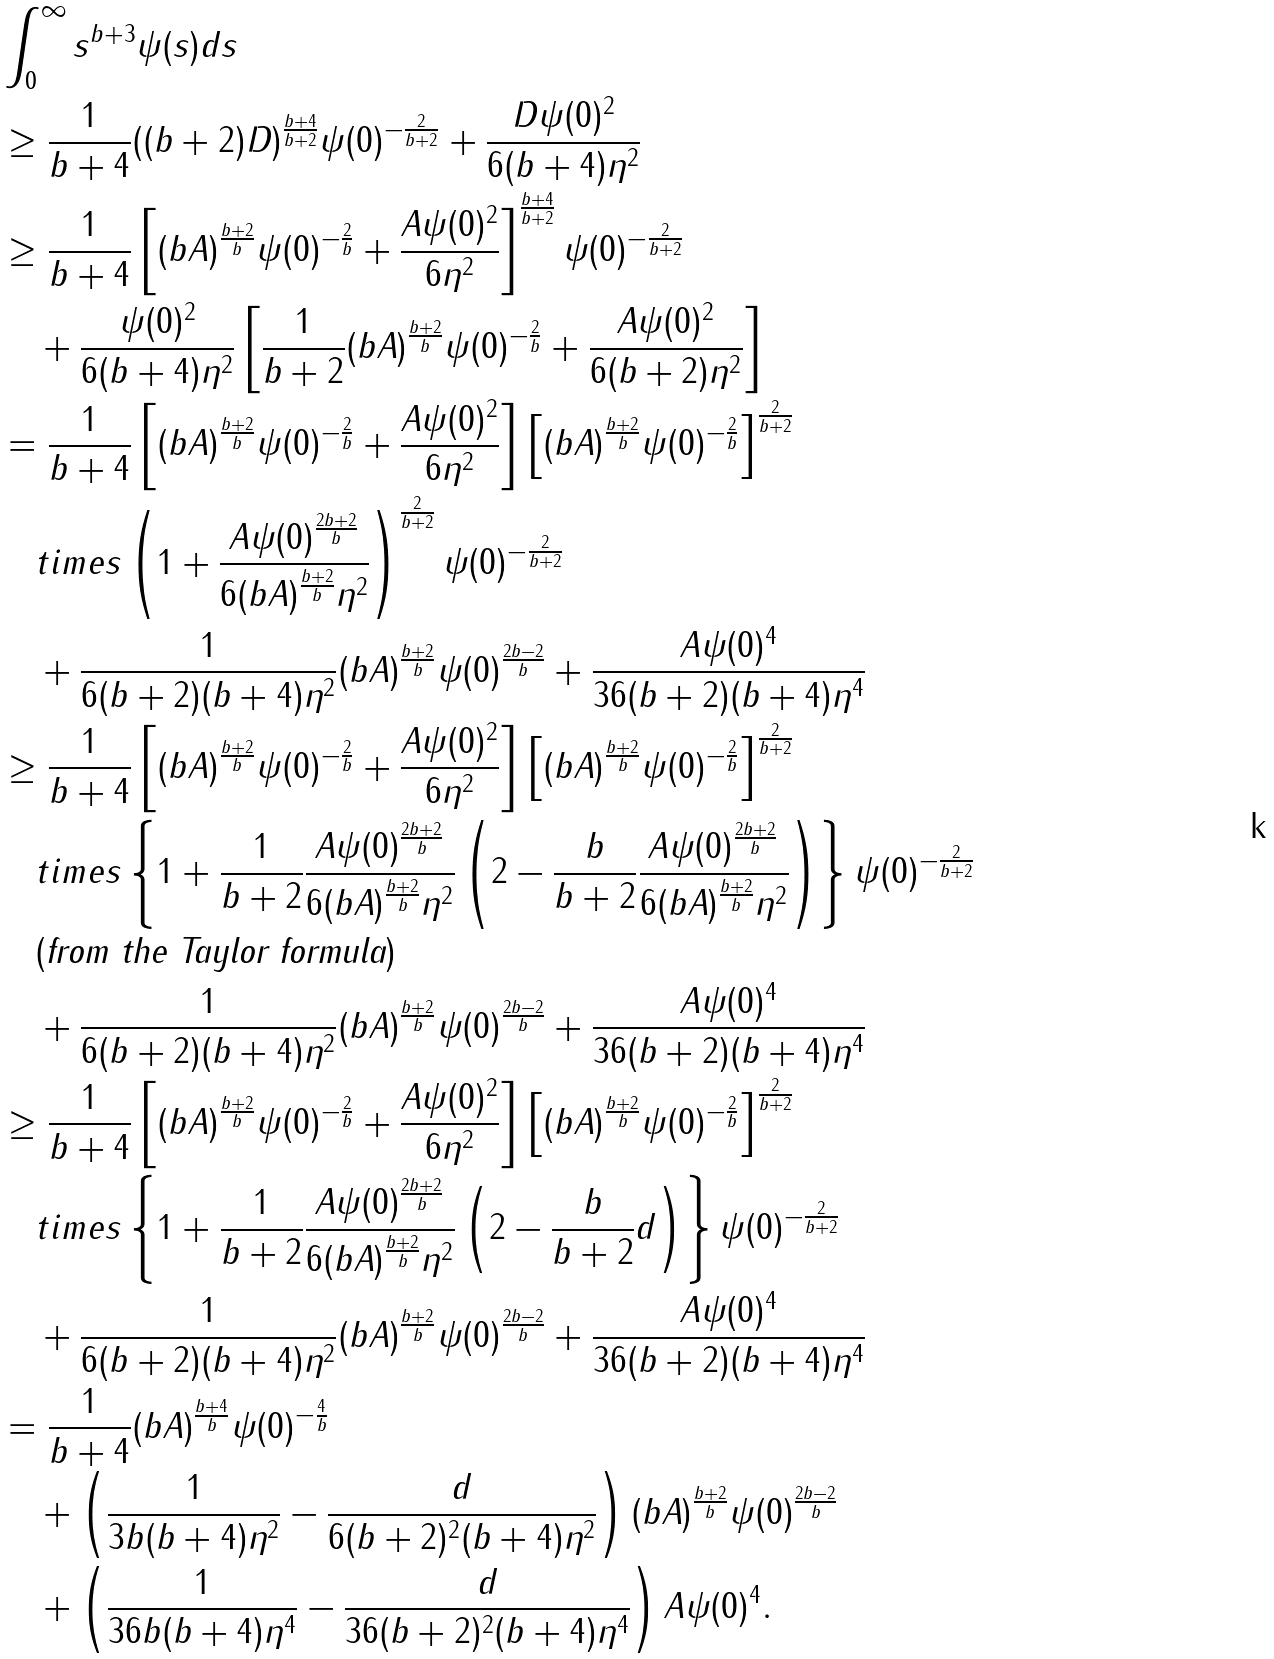<formula> <loc_0><loc_0><loc_500><loc_500>& \int _ { 0 } ^ { \infty } s ^ { b + 3 } \psi ( s ) d s \\ & \geq \frac { 1 } { b + 4 } ( ( b + 2 ) D ) ^ { \frac { b + 4 } { b + 2 } } \psi ( 0 ) ^ { - \frac { 2 } { b + 2 } } + \frac { D \psi ( 0 ) ^ { 2 } } { 6 ( b + 4 ) \eta ^ { 2 } } \\ & \geq \frac { 1 } { b + 4 } \left [ ( b A ) ^ { \frac { b + 2 } { b } } \psi ( 0 ) ^ { - \frac { 2 } { b } } + \frac { A \psi ( 0 ) ^ { 2 } } { 6 \eta ^ { 2 } } \right ] ^ { \frac { b + 4 } { b + 2 } } \psi ( 0 ) ^ { - \frac { 2 } { b + 2 } } \\ & \quad + \frac { \psi ( 0 ) ^ { 2 } } { 6 ( b + 4 ) \eta ^ { 2 } } \left [ \frac { 1 } { b + 2 } ( b A ) ^ { \frac { b + 2 } { b } } \psi ( 0 ) ^ { - \frac { 2 } { b } } + \frac { A \psi ( 0 ) ^ { 2 } } { 6 ( b + 2 ) \eta ^ { 2 } } \right ] \\ & = \frac { 1 } { b + 4 } \left [ ( b A ) ^ { \frac { b + 2 } { b } } \psi ( 0 ) ^ { - \frac { 2 } { b } } + \frac { A \psi ( 0 ) ^ { 2 } } { 6 \eta ^ { 2 } } \right ] \left [ ( b A ) ^ { \frac { b + 2 } { b } } \psi ( 0 ) ^ { - \frac { 2 } { b } } \right ] ^ { \frac { 2 } { b + 2 } } \\ & \quad t i m e s \left ( 1 + \frac { A \psi ( 0 ) ^ { \frac { 2 b + 2 } { b } } } { 6 ( b A ) ^ { \frac { b + 2 } { b } } \eta ^ { 2 } } \right ) ^ { \frac { 2 } { b + 2 } } \psi ( 0 ) ^ { - \frac { 2 } { b + 2 } } \\ & \quad + \frac { 1 } { 6 ( b + 2 ) ( b + 4 ) \eta ^ { 2 } } ( b A ) ^ { \frac { b + 2 } { b } } \psi ( 0 ) ^ { \frac { 2 b - 2 } { b } } + \frac { A \psi ( 0 ) ^ { 4 } } { 3 6 ( b + 2 ) ( b + 4 ) \eta ^ { 4 } } \\ & \geq \frac { 1 } { b + 4 } \left [ ( b A ) ^ { \frac { b + 2 } { b } } \psi ( 0 ) ^ { - \frac { 2 } { b } } + \frac { A \psi ( 0 ) ^ { 2 } } { 6 \eta ^ { 2 } } \right ] \left [ ( b A ) ^ { \frac { b + 2 } { b } } \psi ( 0 ) ^ { - \frac { 2 } { b } } \right ] ^ { \frac { 2 } { b + 2 } } \\ & \quad t i m e s \left \{ 1 + \frac { 1 } { b + 2 } \frac { A \psi ( 0 ) ^ { \frac { 2 b + 2 } { b } } } { 6 ( b A ) ^ { \frac { b + 2 } { b } } \eta ^ { 2 } } \left ( 2 - \frac { b } { b + 2 } \frac { A \psi ( 0 ) ^ { \frac { 2 b + 2 } { b } } } { 6 ( b A ) ^ { \frac { b + 2 } { b } } \eta ^ { 2 } } \right ) \right \} \psi ( 0 ) ^ { - \frac { 2 } { b + 2 } } \\ & \quad ( \text {from the Taylor formula} ) \\ & \quad + \frac { 1 } { 6 ( b + 2 ) ( b + 4 ) \eta ^ { 2 } } ( b A ) ^ { \frac { b + 2 } { b } } \psi ( 0 ) ^ { \frac { 2 b - 2 } { b } } + \frac { A \psi ( 0 ) ^ { 4 } } { 3 6 ( b + 2 ) ( b + 4 ) \eta ^ { 4 } } \\ & \geq \frac { 1 } { b + 4 } \left [ ( b A ) ^ { \frac { b + 2 } { b } } \psi ( 0 ) ^ { - \frac { 2 } { b } } + \frac { A \psi ( 0 ) ^ { 2 } } { 6 \eta ^ { 2 } } \right ] \left [ ( b A ) ^ { \frac { b + 2 } { b } } \psi ( 0 ) ^ { - \frac { 2 } { b } } \right ] ^ { \frac { 2 } { b + 2 } } \\ & \quad t i m e s \left \{ 1 + \frac { 1 } { b + 2 } \frac { A \psi ( 0 ) ^ { \frac { 2 b + 2 } { b } } } { 6 ( b A ) ^ { \frac { b + 2 } { b } } \eta ^ { 2 } } \left ( 2 - \frac { b } { b + 2 } d \right ) \right \} \psi ( 0 ) ^ { - \frac { 2 } { b + 2 } } \\ & \quad + \frac { 1 } { 6 ( b + 2 ) ( b + 4 ) \eta ^ { 2 } } ( b A ) ^ { \frac { b + 2 } { b } } \psi ( 0 ) ^ { \frac { 2 b - 2 } { b } } + \frac { A \psi ( 0 ) ^ { 4 } } { 3 6 ( b + 2 ) ( b + 4 ) \eta ^ { 4 } } \\ & = \frac { 1 } { b + 4 } ( b A ) ^ { \frac { b + 4 } { b } } \psi ( 0 ) ^ { - \frac { 4 } { b } } \\ & \quad + \left ( \frac { 1 } { 3 b ( b + 4 ) \eta ^ { 2 } } - \frac { d } { 6 ( b + 2 ) ^ { 2 } ( b + 4 ) \eta ^ { 2 } } \right ) ( b A ) ^ { \frac { b + 2 } { b } } \psi ( 0 ) ^ { \frac { 2 b - 2 } { b } } \\ & \quad + \left ( \frac { 1 } { 3 6 b ( b + 4 ) \eta ^ { 4 } } - \frac { d } { 3 6 ( b + 2 ) ^ { 2 } ( b + 4 ) \eta ^ { 4 } } \right ) A \psi ( 0 ) ^ { 4 } .</formula> 